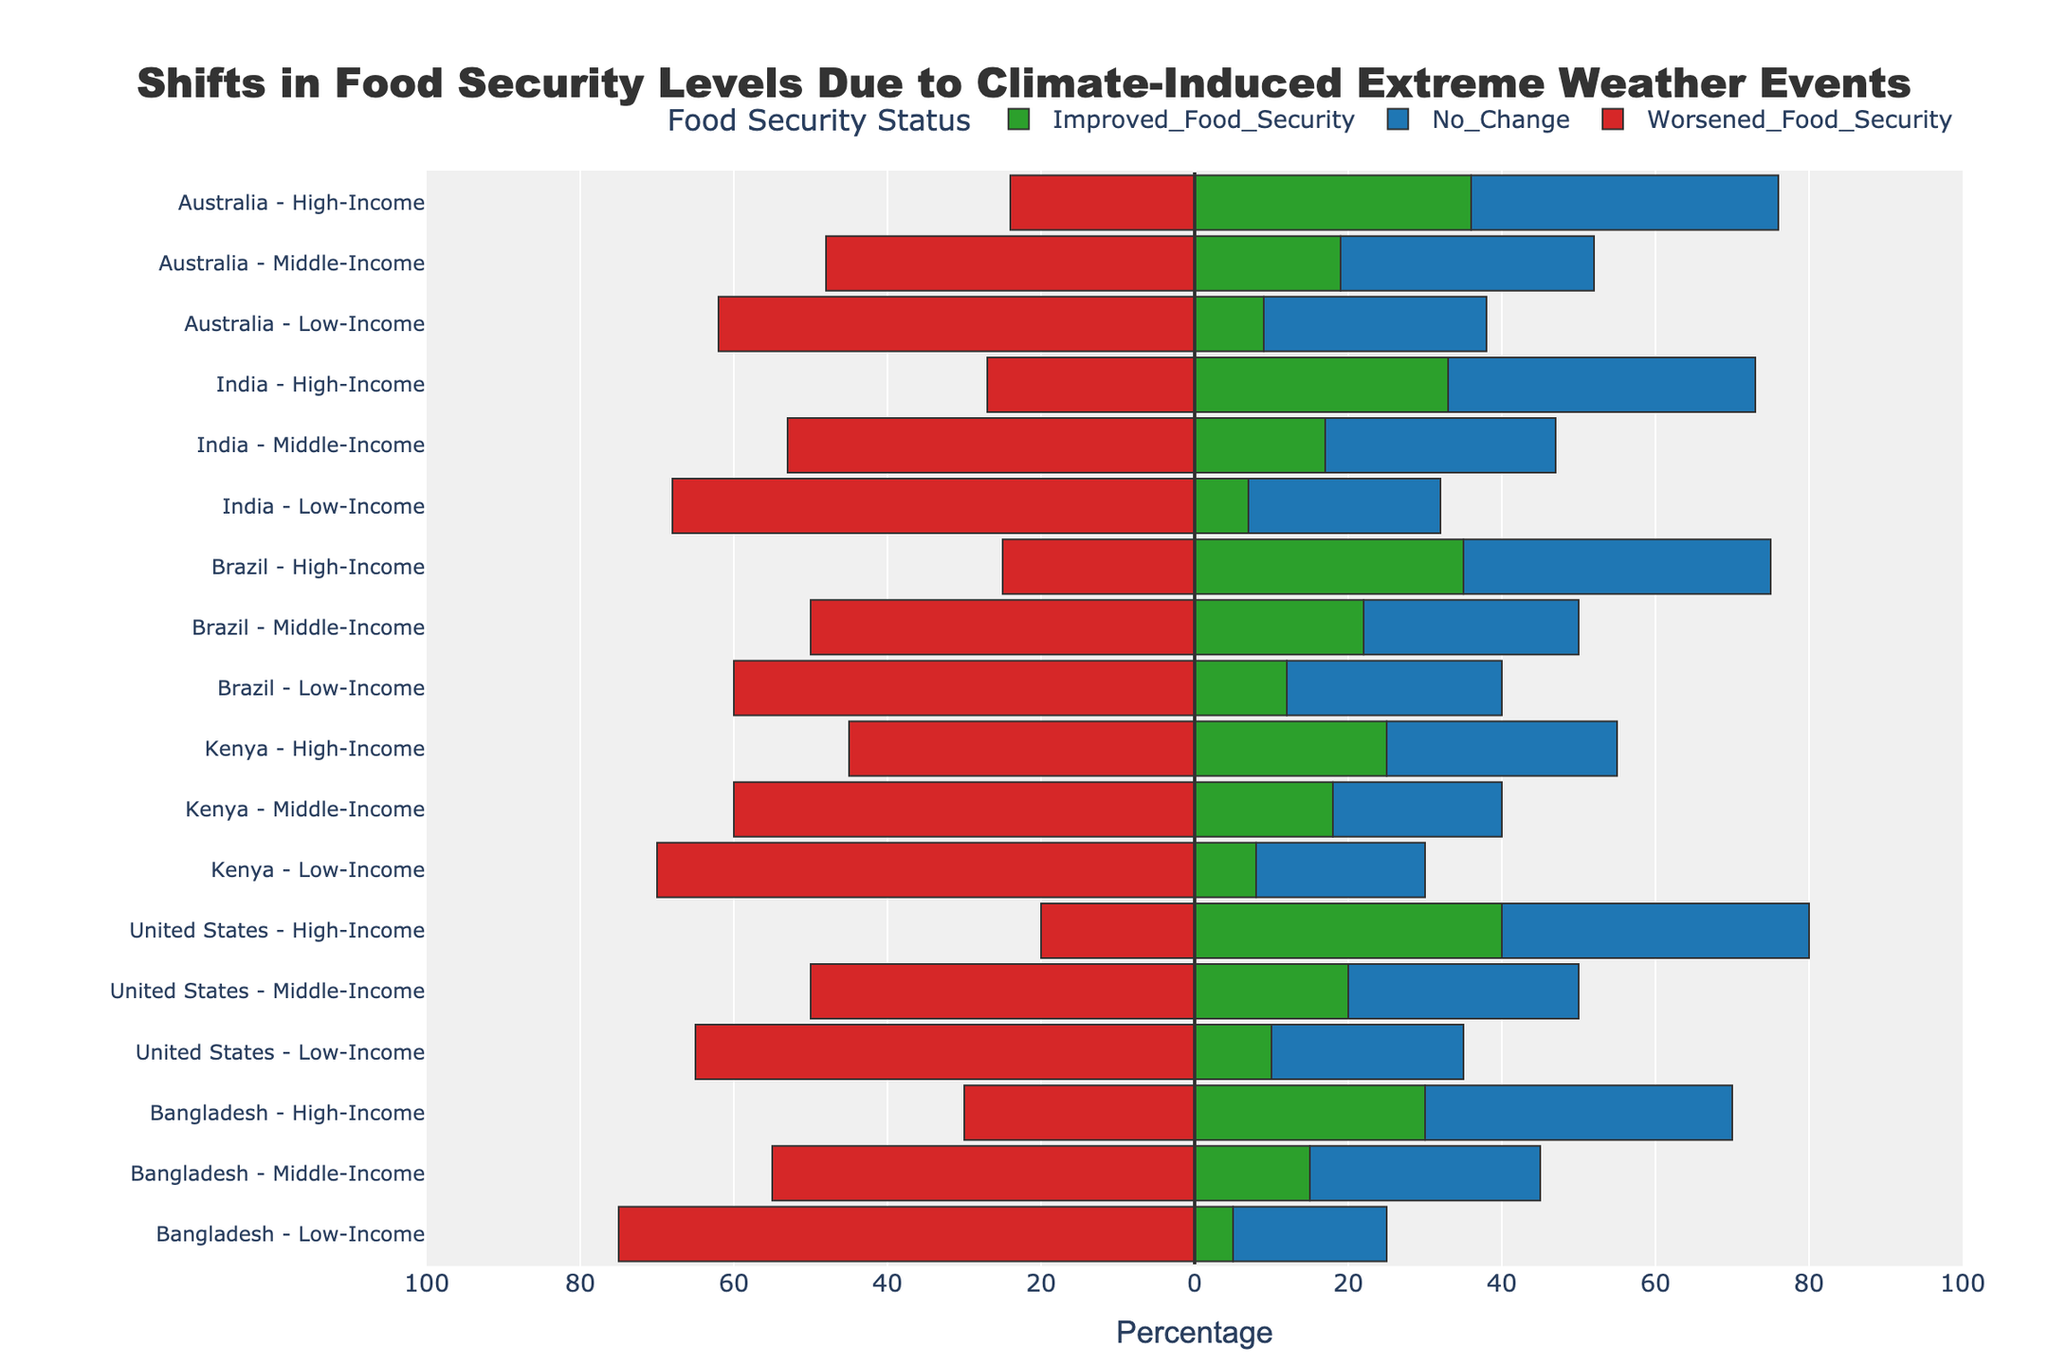Which socio-economic group in Brazil shows the highest percentage of improved food security? Looking at the "Improved Food Security" bars for Brazil, the high-income group has the longest bar representing 35%.
Answer: High-Income Which country has the highest percentage of worsened food security for the low-income group? By comparing the red bars for the low-income group across countries, Bangladesh shows the longest bar at 75%.
Answer: Bangladesh Among middle-income groups, which country experienced the least change in food security levels (combining improved and worsened)? For each country, sum the absolute values of improved and worsened percentages for the middle-income group. The calculations are:
- Bangladesh: 15 + 55 = 70
- United States: 20 + 50 = 70
- Kenya: 18 + 60 = 78
- Brazil: 22 + 50 = 72
- India: 17 + 53 = 70
- Australia: 19 + 48 = 67
Australia has the smallest sum at 67.
Answer: Australia Compare the food security shifts for middle-income groups in Bangladesh and Brazil: which country shows a greater rate of improvement? "Improved Food Security" bars for the middle-income groups show that Bangladesh has 15% improvement while Brazil has 22%.
Answer: Brazil Which socio-economic group in Kenya has the highest percentage of no change in food security? By looking at the "No Change" bars for Kenya, both low-income and middle-income groups have 22%, and the high-income group has 30%. The high-income group shows the highest percentage.
Answer: High-Income In India, how does the percentage of worsened food security among the high-income group compare to that of middle-income? The red bar for worsened food security in India shows 27% for high-income and 53% for middle-income.
Answer: Middle-Income shows higher percentage Which socio-economic group in Australia has the lowest percentage of worsened food security? Comparing the red bars for Australia, the high-income group shows 24%, middle-income 48%, and low-income 62%. The high-income group has the lowest percentage.
Answer: High-Income What's the average percentage of improved food security across all socio-economic groups in the United States? Calculate the average of improved food security percentages:
(10 + 20 + 40) / 3 = 70 / 3 ≈ 23.33%
Answer: 23.33% How does the percentage of improved food security in the high-income group of Kenya compare to the middle-income group in Australia? The green bar for Kenya's high-income group shows 25%, while the middle-income group in Australia shows 19%.
Answer: Kenya 